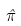Convert formula to latex. <formula><loc_0><loc_0><loc_500><loc_500>\hat { \pi }</formula> 